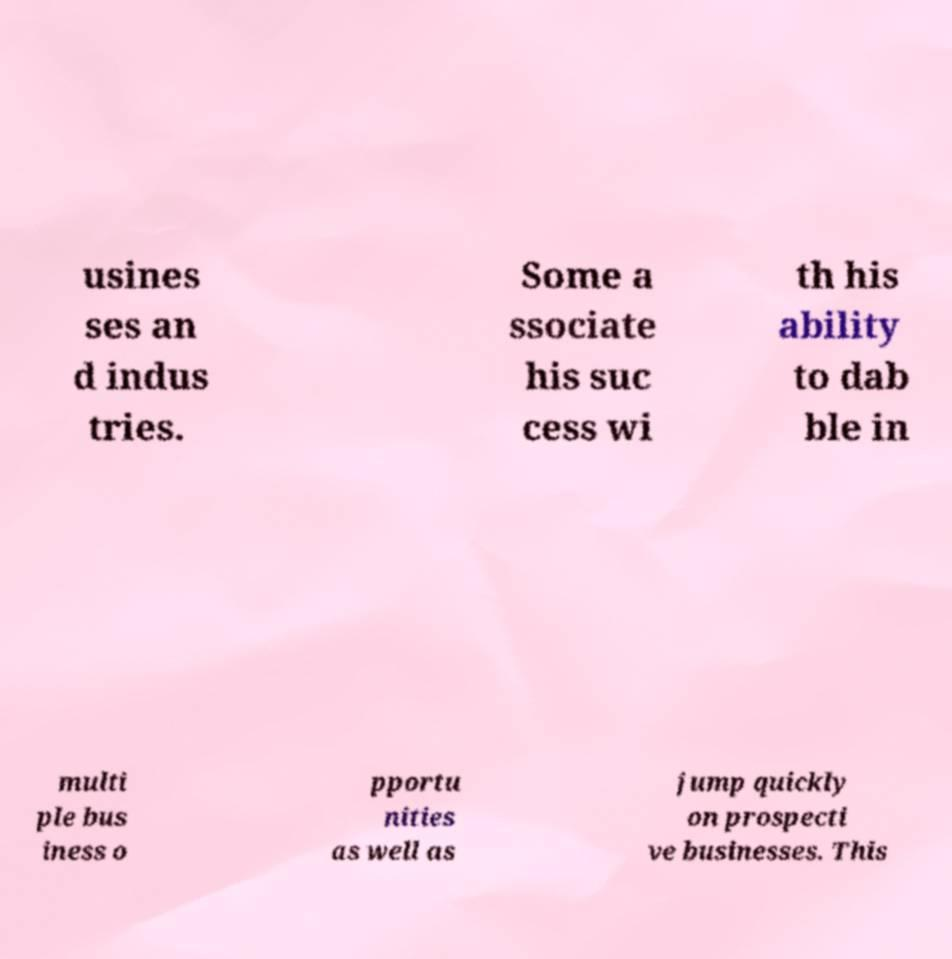For documentation purposes, I need the text within this image transcribed. Could you provide that? usines ses an d indus tries. Some a ssociate his suc cess wi th his ability to dab ble in multi ple bus iness o pportu nities as well as jump quickly on prospecti ve businesses. This 